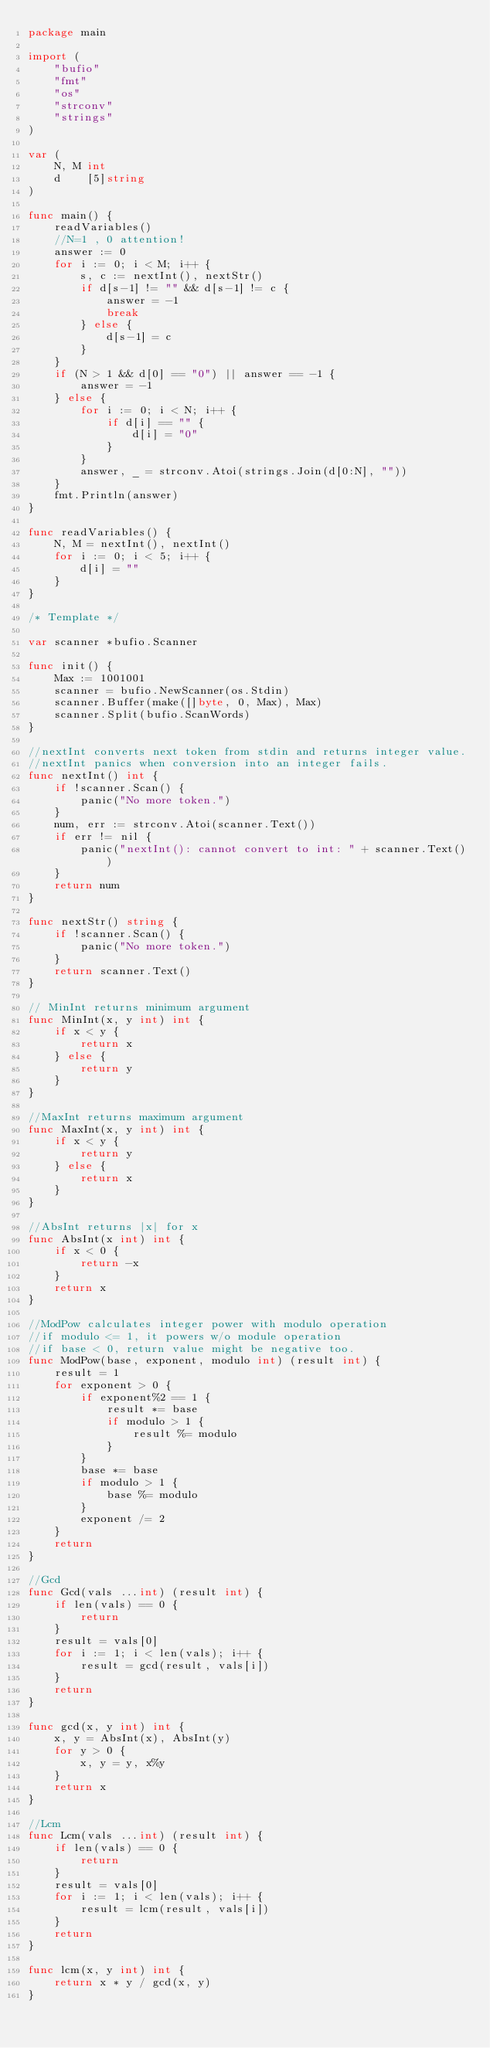<code> <loc_0><loc_0><loc_500><loc_500><_Go_>package main

import (
	"bufio"
	"fmt"
	"os"
	"strconv"
	"strings"
)

var (
	N, M int
	d    [5]string
)

func main() {
	readVariables()
	//N=1 , 0 attention!
	answer := 0
	for i := 0; i < M; i++ {
		s, c := nextInt(), nextStr()
		if d[s-1] != "" && d[s-1] != c {
			answer = -1
			break
		} else {
			d[s-1] = c
		}
	}
	if (N > 1 && d[0] == "0") || answer == -1 {
		answer = -1
	} else {
		for i := 0; i < N; i++ {
			if d[i] == "" {
				d[i] = "0"
			}
		}
		answer, _ = strconv.Atoi(strings.Join(d[0:N], ""))
	}
	fmt.Println(answer)
}

func readVariables() {
	N, M = nextInt(), nextInt()
	for i := 0; i < 5; i++ {
		d[i] = ""
	}
}

/* Template */

var scanner *bufio.Scanner

func init() {
	Max := 1001001
	scanner = bufio.NewScanner(os.Stdin)
	scanner.Buffer(make([]byte, 0, Max), Max)
	scanner.Split(bufio.ScanWords)
}

//nextInt converts next token from stdin and returns integer value.
//nextInt panics when conversion into an integer fails.
func nextInt() int {
	if !scanner.Scan() {
		panic("No more token.")
	}
	num, err := strconv.Atoi(scanner.Text())
	if err != nil {
		panic("nextInt(): cannot convert to int: " + scanner.Text())
	}
	return num
}

func nextStr() string {
	if !scanner.Scan() {
		panic("No more token.")
	}
	return scanner.Text()
}

// MinInt returns minimum argument
func MinInt(x, y int) int {
	if x < y {
		return x
	} else {
		return y
	}
}

//MaxInt returns maximum argument
func MaxInt(x, y int) int {
	if x < y {
		return y
	} else {
		return x
	}
}

//AbsInt returns |x| for x
func AbsInt(x int) int {
	if x < 0 {
		return -x
	}
	return x
}

//ModPow calculates integer power with modulo operation
//if modulo <= 1, it powers w/o module operation
//if base < 0, return value might be negative too.
func ModPow(base, exponent, modulo int) (result int) {
	result = 1
	for exponent > 0 {
		if exponent%2 == 1 {
			result *= base
			if modulo > 1 {
				result %= modulo
			}
		}
		base *= base
		if modulo > 1 {
			base %= modulo
		}
		exponent /= 2
	}
	return
}

//Gcd
func Gcd(vals ...int) (result int) {
	if len(vals) == 0 {
		return
	}
	result = vals[0]
	for i := 1; i < len(vals); i++ {
		result = gcd(result, vals[i])
	}
	return
}

func gcd(x, y int) int {
	x, y = AbsInt(x), AbsInt(y)
	for y > 0 {
		x, y = y, x%y
	}
	return x
}

//Lcm
func Lcm(vals ...int) (result int) {
	if len(vals) == 0 {
		return
	}
	result = vals[0]
	for i := 1; i < len(vals); i++ {
		result = lcm(result, vals[i])
	}
	return
}

func lcm(x, y int) int {
	return x * y / gcd(x, y)
}
</code> 